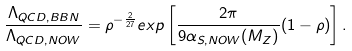<formula> <loc_0><loc_0><loc_500><loc_500>\frac { \Lambda _ { Q C D , B B N } } { \Lambda _ { Q C D , N O W } } = \rho ^ { - \frac { 2 } { 2 7 } } e x p \left [ \frac { 2 \pi } { 9 \alpha _ { S , N O W } ( M _ { Z } ) } ( 1 - \rho ) \right ] .</formula> 